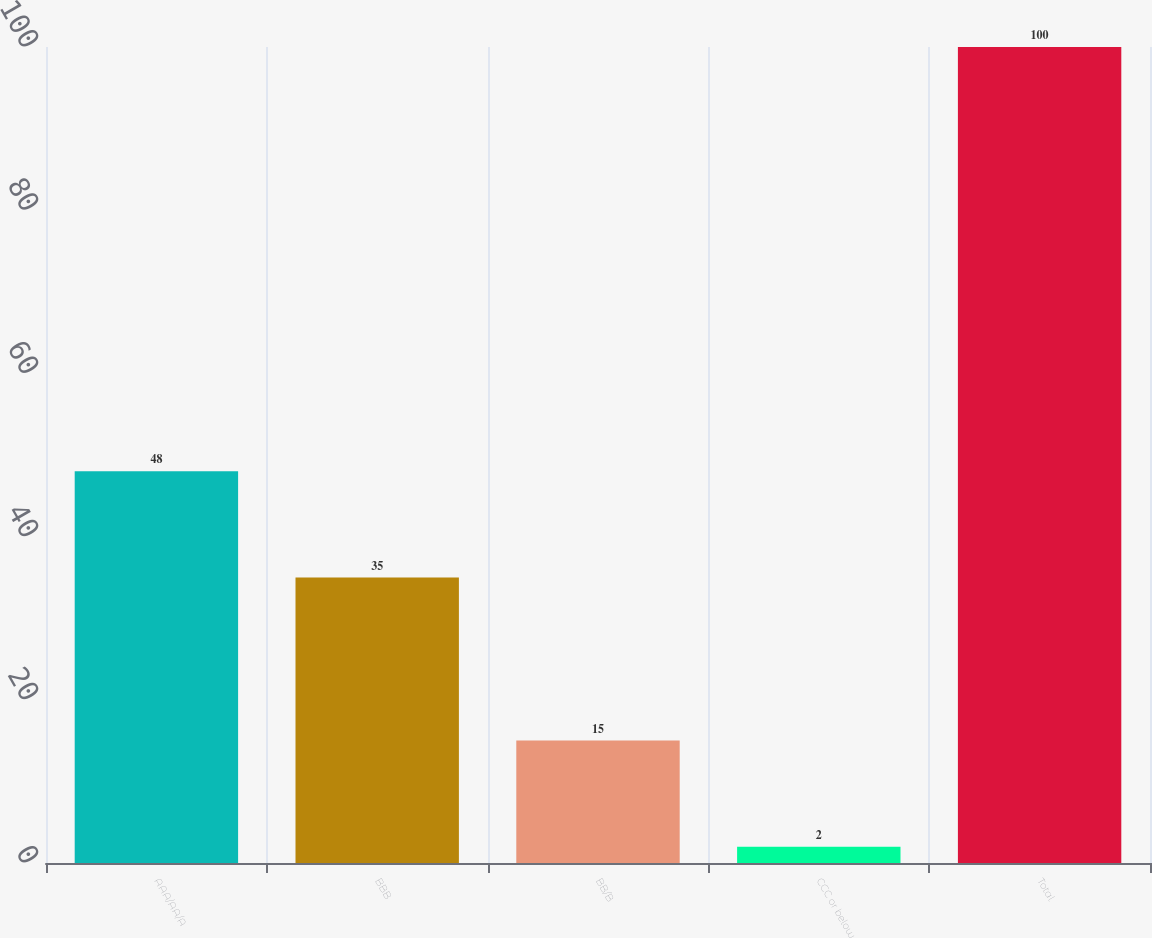Convert chart to OTSL. <chart><loc_0><loc_0><loc_500><loc_500><bar_chart><fcel>AAA/AA/A<fcel>BBB<fcel>BB/B<fcel>CCC or below<fcel>Total<nl><fcel>48<fcel>35<fcel>15<fcel>2<fcel>100<nl></chart> 